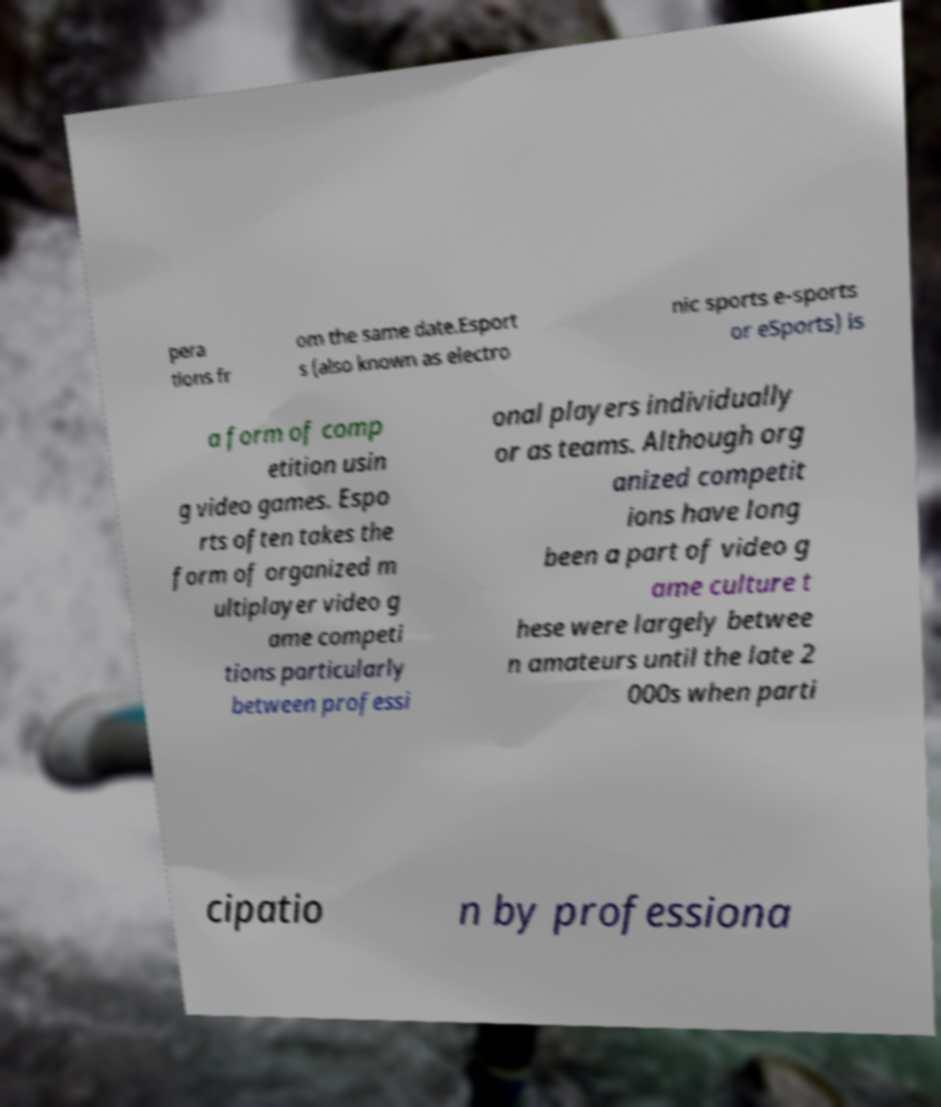Please identify and transcribe the text found in this image. pera tions fr om the same date.Esport s (also known as electro nic sports e-sports or eSports) is a form of comp etition usin g video games. Espo rts often takes the form of organized m ultiplayer video g ame competi tions particularly between professi onal players individually or as teams. Although org anized competit ions have long been a part of video g ame culture t hese were largely betwee n amateurs until the late 2 000s when parti cipatio n by professiona 